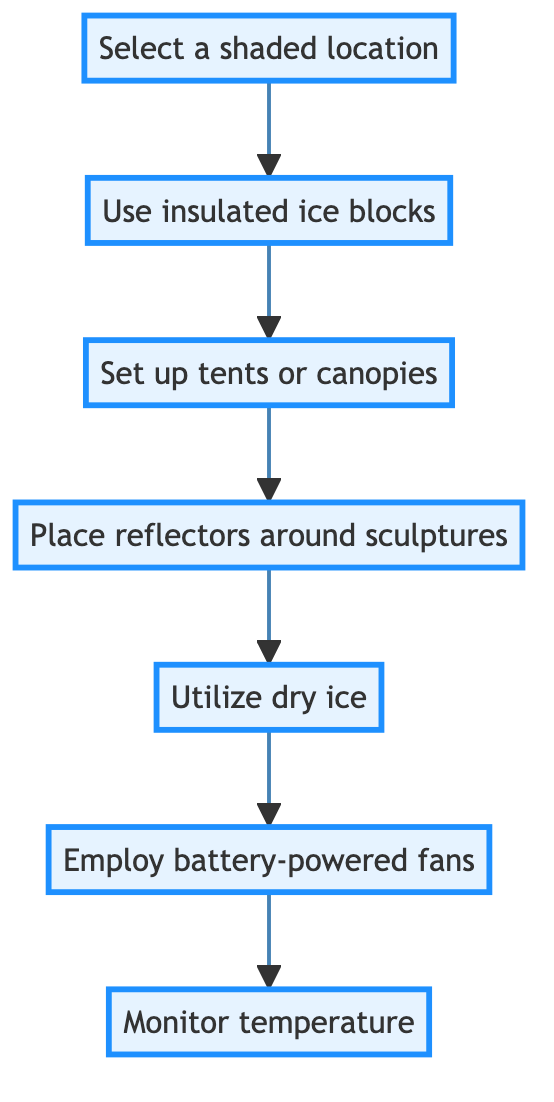What is the first step in the diagram? The first step in the diagram is represented as node A, which states "Select a shaded location."
Answer: Select a shaded location How many steps are there in total? By counting the nodes in the flowchart, there are seven distinct steps listed: A, B, C, D, E, F, and G.
Answer: 7 What step follows "Place reflectors around sculptures"? "Place reflectors around sculptures" is node D, and the next step is node E, which states "Utilize dry ice."
Answer: Utilize dry ice Which step involves using dry ice? The step that specifically mentions dry ice is represented as node E, which reads "Utilize dry ice."
Answer: Utilize dry ice What does monitoring temperature entail? Monitoring temperature is expressed in node G as "Monitor temperature," which means to regularly check the ambient temperature using a digital thermometer.
Answer: Monitor temperature Which steps require setting up or placing items around the sculptures? The relevant steps include node C ("Set up tents or canopies"), node D ("Place reflectors around sculptures"), and node E ("Utilize dry ice").
Answer: Set up tents or canopies, Place reflectors around sculptures, Utilize dry ice In what order do dry ice and battery-powered fans appear in the steps? Dry ice appears in step E, and battery-powered fans are in step F, indicating that dry ice is set up before the fans are used to circulate air.
Answer: Dry ice, battery-powered fans What is the relationship between the steps "Use insulated ice blocks" and "Set up tents or canopies"? "Use insulated ice blocks" is node B, and it directly leads to "Set up tents or canopies," which is node C. This indicates that using insulated ice blocks is a prerequisite for setting up tents or canopies.
Answer: Directly leads to How do the steps ensure the sculptures remain cold? The combination of shaded location selection, insulated ice blocks, tents or canopies, reflectors, dry ice, fans, and temperature monitoring works together to create a cooler environment for the sculptures, preventing them from melting.
Answer: Cool environment 